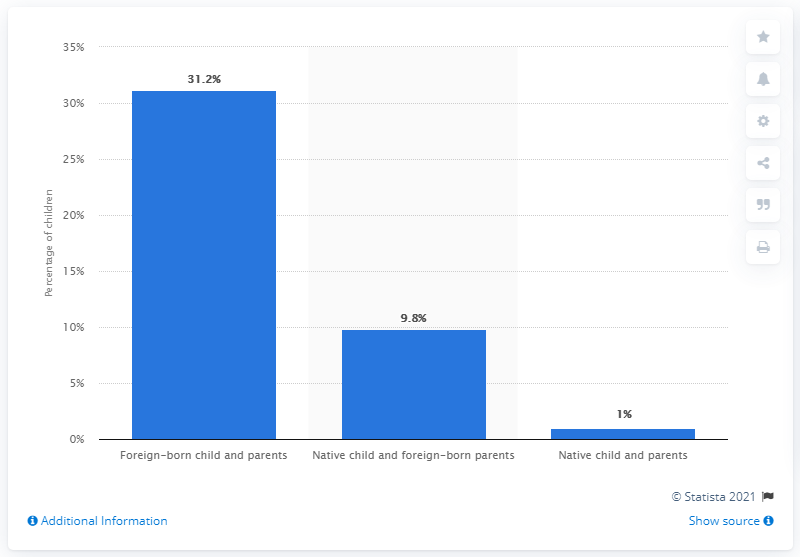Indicate a few pertinent items in this graphic. In 2018, approximately 31.2% of children with foreign-born parents who spoke a language other than English at home 